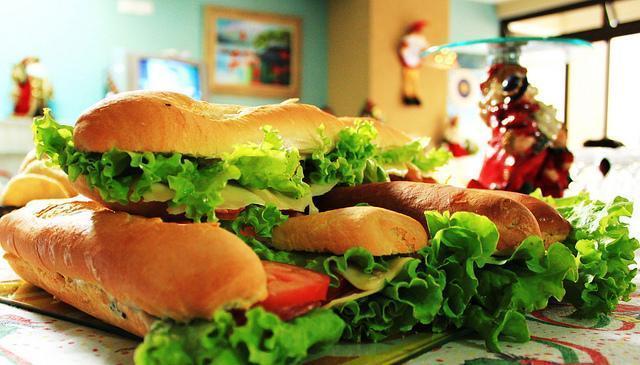How many sandwiches are visible?
Give a very brief answer. 4. How many people are there?
Give a very brief answer. 0. 